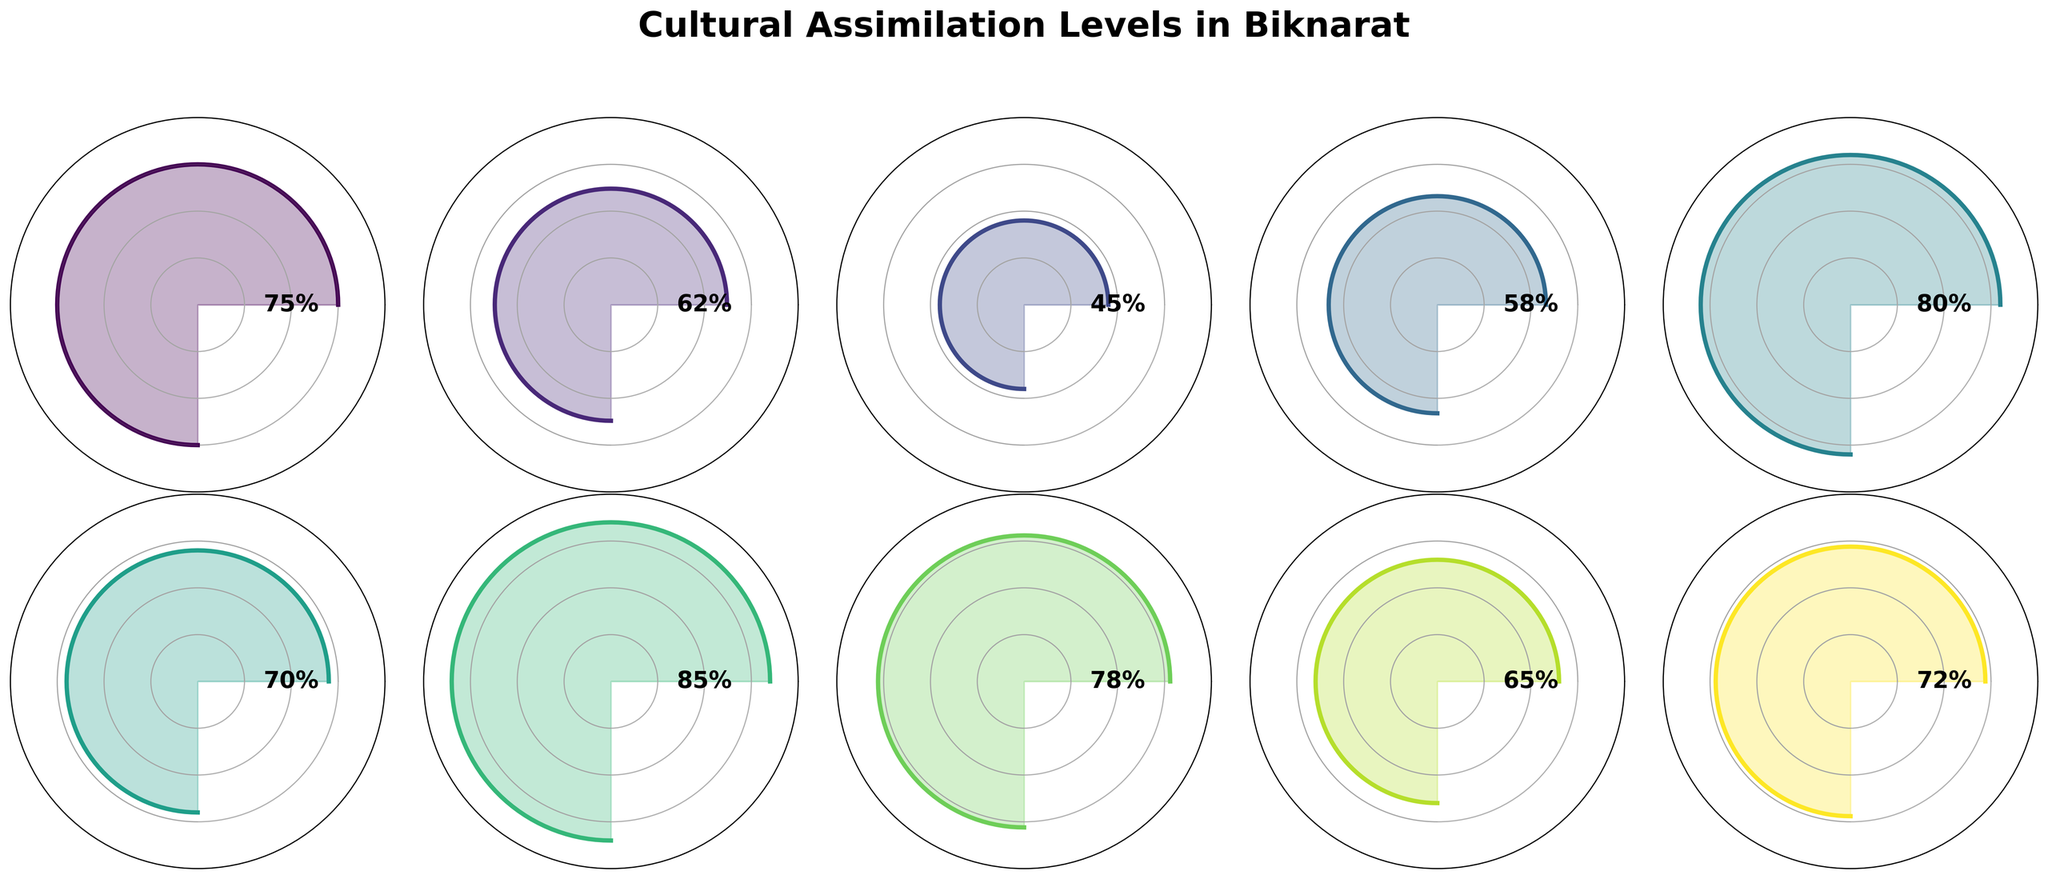What is the highest value for Cultural Assimilation Levels in Biknarat? To find the highest value, scan through all the categories and their corresponding values. The highest value among them is for Culinary Fusion at 80%.
Answer: 80% Which category has the lowest assimilation level value? Look at each category and identify their values. The lowest value is Traditional Customs Retention at 45%.
Answer: Traditional Customs Retention What is the average value of all Cultural Assimilation Levels? Add all the values together (75 + 62 + 45 + 58 + 80 + 70 + 85 + 78 + 65 + 72 = 690) and divide by the number of categories (10). The average value is 690 / 10 = 69.
Answer: 69 How many categories have a value greater than 70%? Count the number of categories where the value exceeds 70. The categories are: Language Integration, Culinary Fusion, Educational Integration, Workplace Collaboration, and Cultural Events Attendance. There are 5 such categories.
Answer: 5 Which category has a value closest to 60%? Examine the values and find the one nearest to 60. The Intermarriage Rate has a value of 62%, which is the closest to 60%.
Answer: Intermarriage Rate What is the sum of values for categories related to integration aspects (Language Integration, Educational Integration, Workplace Collaboration)? Add the values of Language Integration (75), Educational Integration (85), and Workplace Collaboration (78). The sum is 75 + 85 + 78 = 238.
Answer: 238 Which has a higher value: Mixed Neighborhood Residency or Shared Festivals Participation? Compare the values of Mixed Neighborhood Residency (65) and Shared Festivals Participation (70). Shared Festivals Participation has a higher value.
Answer: Shared Festivals Participation By how much does Culinary Fusion exceed Religious Practices Blend? Subtract the value of Religious Practices Blend (58) from Culinary Fusion (80). The difference is 80 - 58 = 22.
Answer: 22 What is the median value of the Cultural Assimilation Levels? Arrange the values in ascending order (45, 58, 62, 65, 70, 72, 75, 78, 80, 85) and find the middle value. Since there are 10 values, the median is the average of the 5th and 6th values: (70 + 72) / 2 = 71.
Answer: 71 